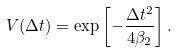<formula> <loc_0><loc_0><loc_500><loc_500>V ( \Delta t ) = \exp \left [ - \frac { \Delta t ^ { 2 } } { 4 \beta _ { 2 } } \right ] .</formula> 